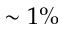Convert formula to latex. <formula><loc_0><loc_0><loc_500><loc_500>\sim 1 \%</formula> 